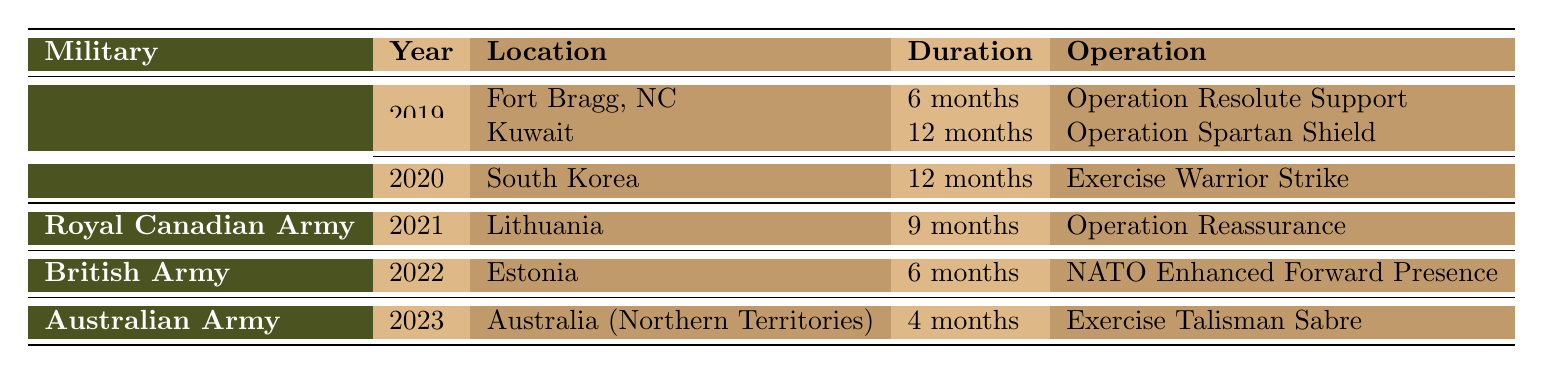What military unit was deployed to Kuwait in 2019? The table contains a row for the US Army under the year 2019 which lists Kuwait as one of the locations.
Answer: US Army How long was the US Army deployed to South Korea? From the table, the US Army has a deployment to South Korea for the year 2020, and the duration is specified as 12 months.
Answer: 12 months Did the Royal Canadian Army deploy to Lithuania in 2021? The table indicates that the Royal Canadian Army has a deployment listed for Lithuania in the year 2021.
Answer: Yes Which operation took place during the British Army's deployment in 2022? Looking at the British Army's entry in the table for 2022, the operation listed is "NATO Enhanced Forward Presence."
Answer: NATO Enhanced Forward Presence What is the total duration of deployments for the US Army in 2019? There are two deployments listed for the US Army in 2019: Fort Bragg, NC for 6 months and Kuwait for 12 months. Adding these durations gives: 6 + 12 = 18.
Answer: 18 months Was the duration of the deployment to Estonia longer than that to Australia (Northern Territories)? The table states that the deployment to Estonia in 2022 was for 6 months, while the deployment to Australia (Northern Territories) in 2023 was for 4 months. Since 6 is greater than 4, the answer is true.
Answer: Yes What is the average duration of the deployments listed from 2019 to 2023? To find the average, we first add the durations: 6 + 12 + 12 + 9 + 6 + 4 = 49 months. There are 6 deployments, thus the average is 49/6 = 8.17 (approximately).
Answer: Approximately 8.17 months Which military unit had the shortest deployment duration in the table? The Australian Army had a deployment duration of 4 months in 2023, which is the shortest when compared to other durations in the table.
Answer: Australian Army How many different operations did the US Army conduct over the specified years? The US Army has operations for 2019 (2 operations) and 2020 (1 operation), totaling 3 distinct operations.
Answer: 3 operations 